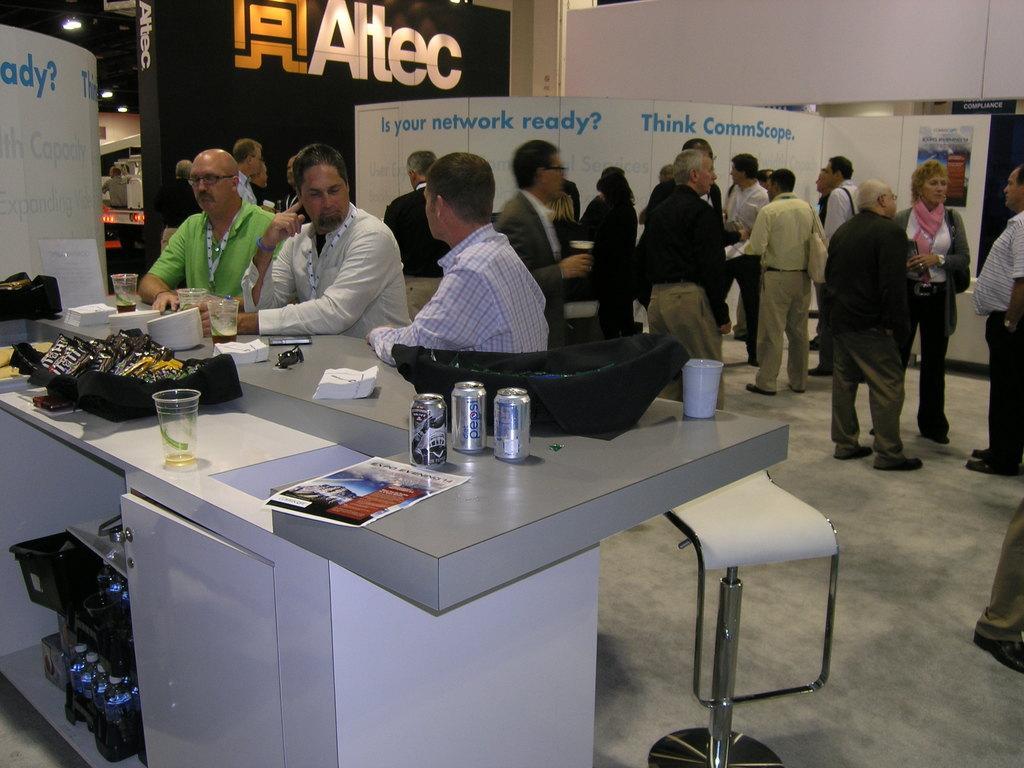Can you describe this image briefly? in the picture standing and three persons are sitting and discussing something,there is a table in front of them,on the table there are different present on it. 